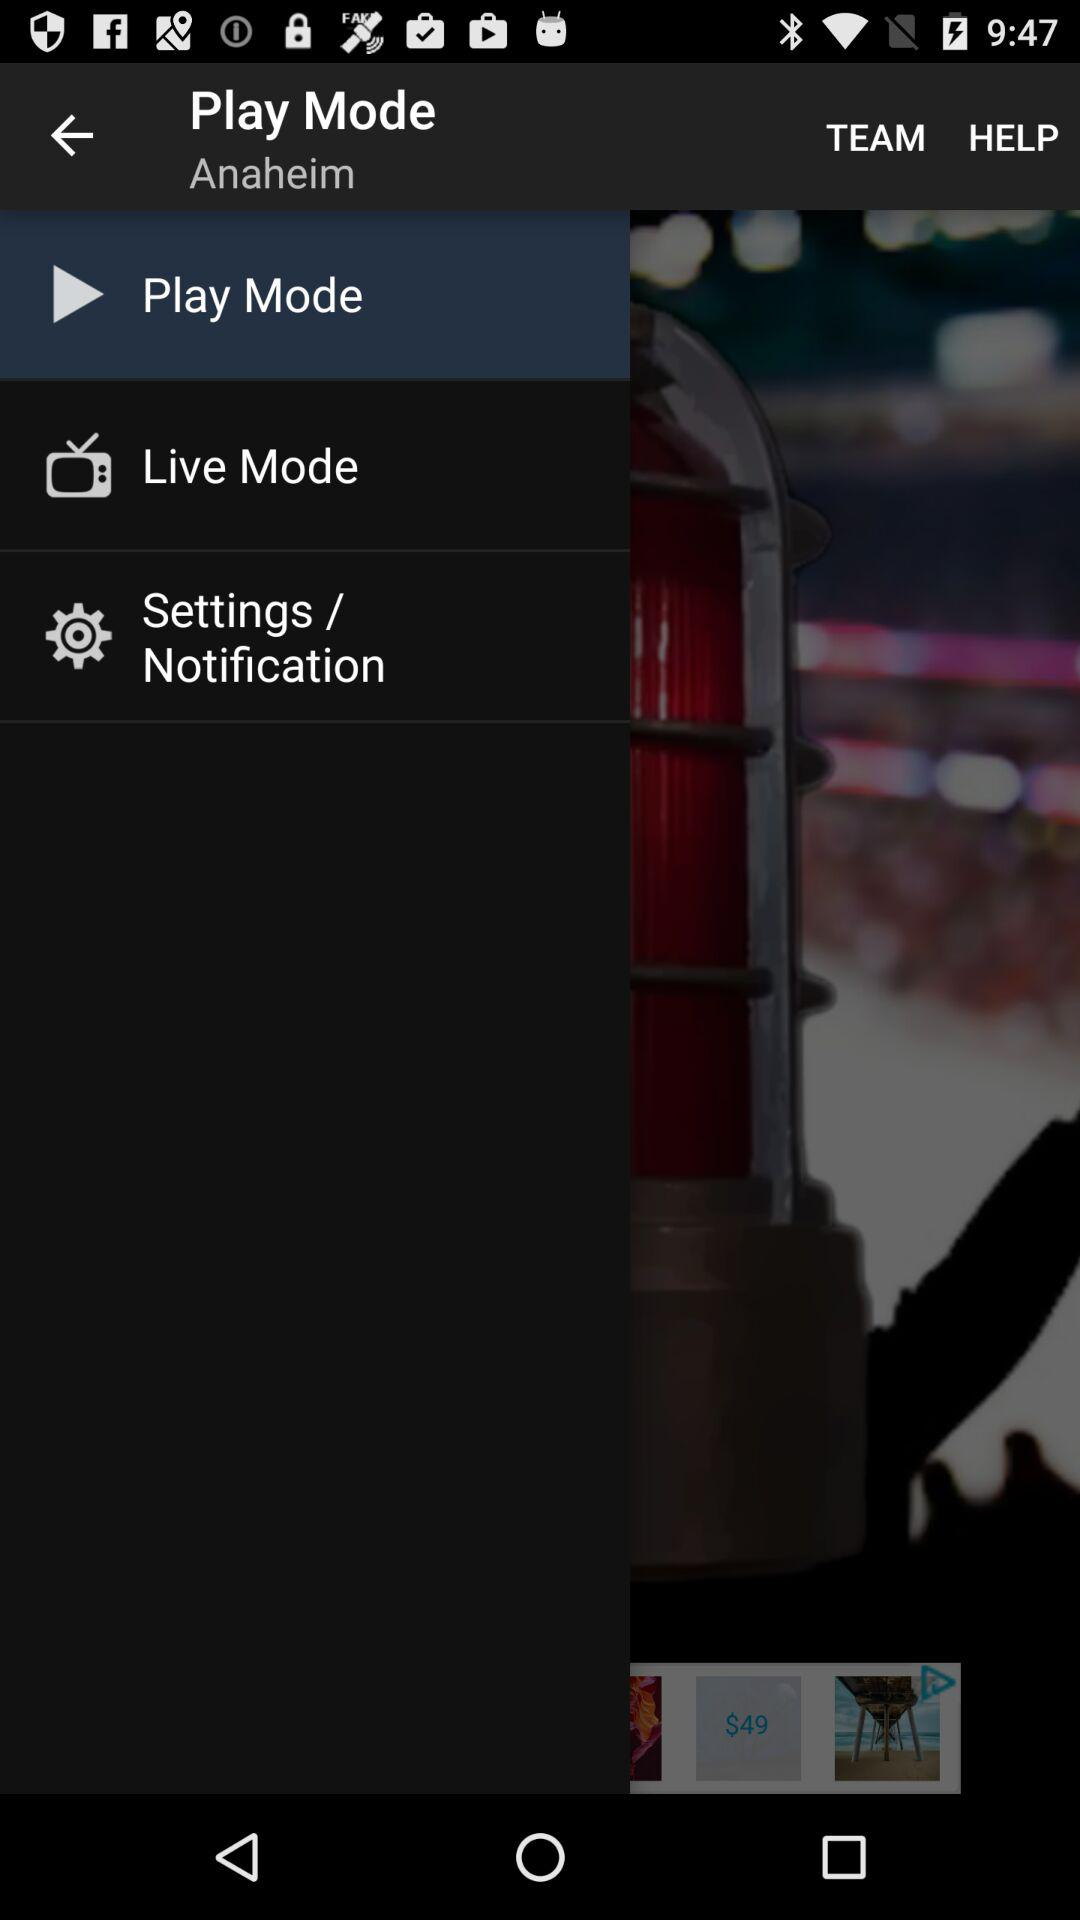How many notifications are there in "Live Mode"?
When the provided information is insufficient, respond with <no answer>. <no answer> 